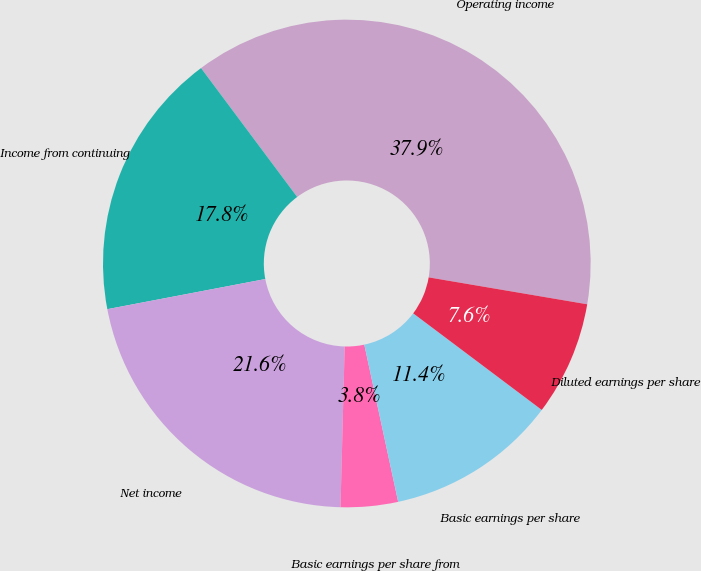<chart> <loc_0><loc_0><loc_500><loc_500><pie_chart><fcel>Operating income<fcel>Income from continuing<fcel>Net income<fcel>Basic earnings per share from<fcel>Basic earnings per share<fcel>Diluted earnings per share<nl><fcel>37.88%<fcel>17.8%<fcel>21.59%<fcel>3.79%<fcel>11.37%<fcel>7.58%<nl></chart> 